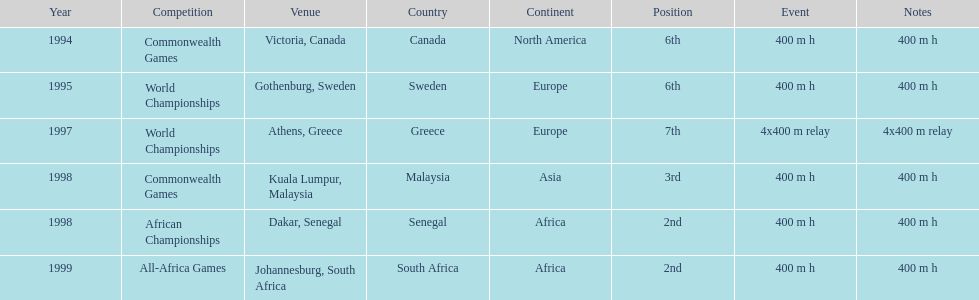What is the name of the last competition? All-Africa Games. 